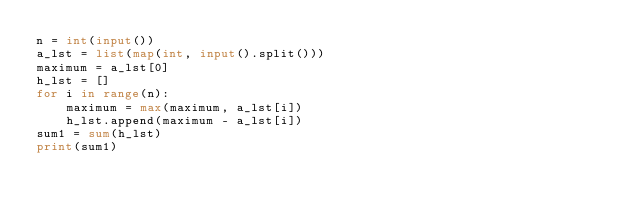Convert code to text. <code><loc_0><loc_0><loc_500><loc_500><_Python_>n = int(input())
a_lst = list(map(int, input().split()))
maximum = a_lst[0]
h_lst = []
for i in range(n):
    maximum = max(maximum, a_lst[i])
    h_lst.append(maximum - a_lst[i])
sum1 = sum(h_lst)
print(sum1)</code> 